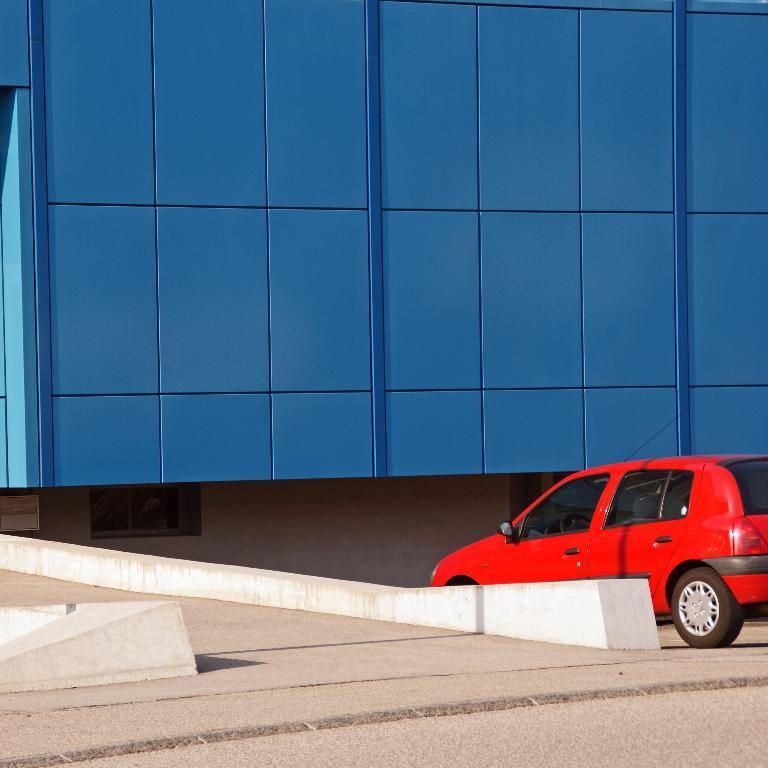In one or two sentences, can you explain what this image depicts? In the image there is red car moving on road on the right side, in front of it, it seems to be a building in blue color, on the left side its a road. 